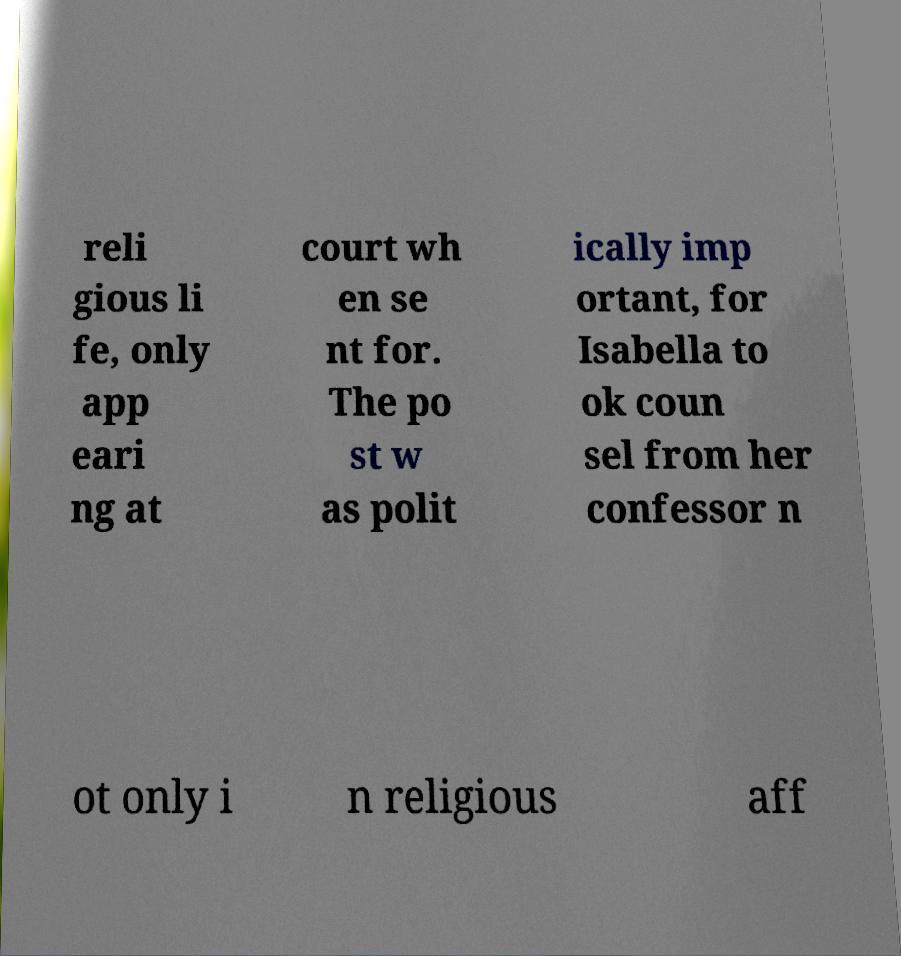Can you read and provide the text displayed in the image?This photo seems to have some interesting text. Can you extract and type it out for me? reli gious li fe, only app eari ng at court wh en se nt for. The po st w as polit ically imp ortant, for Isabella to ok coun sel from her confessor n ot only i n religious aff 